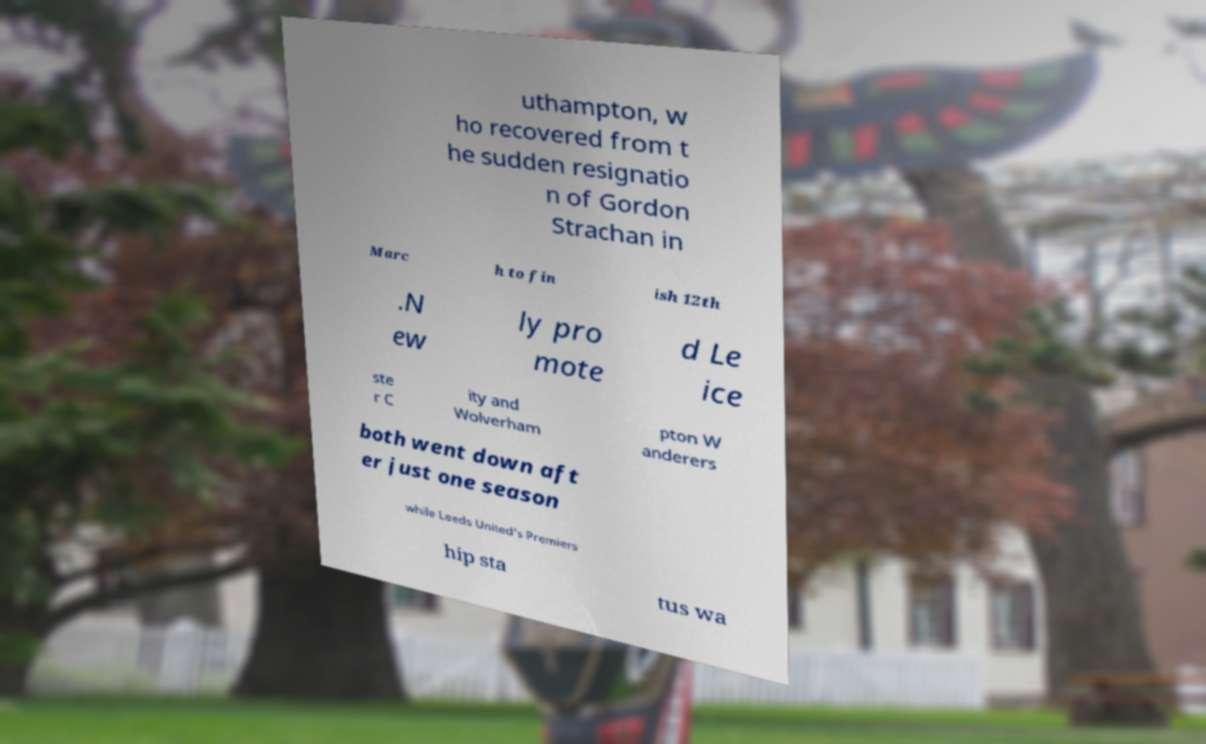Can you read and provide the text displayed in the image?This photo seems to have some interesting text. Can you extract and type it out for me? uthampton, w ho recovered from t he sudden resignatio n of Gordon Strachan in Marc h to fin ish 12th .N ew ly pro mote d Le ice ste r C ity and Wolverham pton W anderers both went down aft er just one season while Leeds United's Premiers hip sta tus wa 